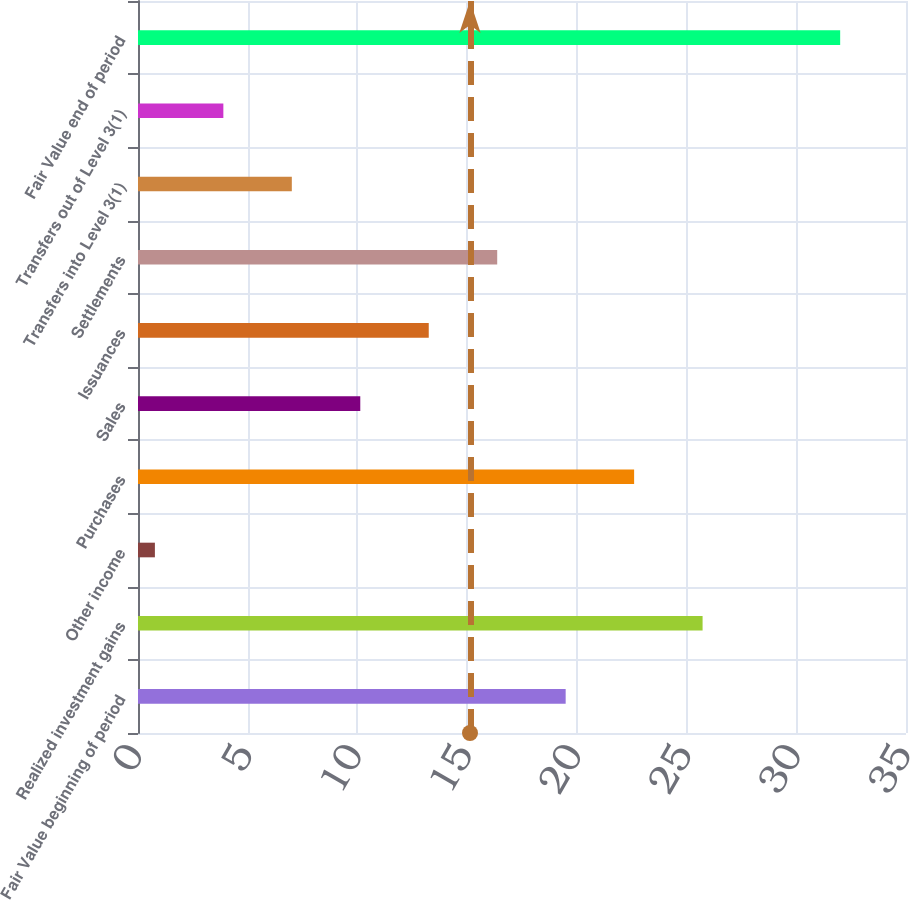Convert chart to OTSL. <chart><loc_0><loc_0><loc_500><loc_500><bar_chart><fcel>Fair Value beginning of period<fcel>Realized investment gains<fcel>Other income<fcel>Purchases<fcel>Sales<fcel>Issuances<fcel>Settlements<fcel>Transfers into Level 3(1)<fcel>Transfers out of Level 3(1)<fcel>Fair Value end of period<nl><fcel>19.49<fcel>25.73<fcel>0.77<fcel>22.61<fcel>10.13<fcel>13.25<fcel>16.37<fcel>7.01<fcel>3.89<fcel>32<nl></chart> 